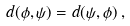Convert formula to latex. <formula><loc_0><loc_0><loc_500><loc_500>d ( \phi , \psi ) = d ( \psi , \phi ) \, ,</formula> 